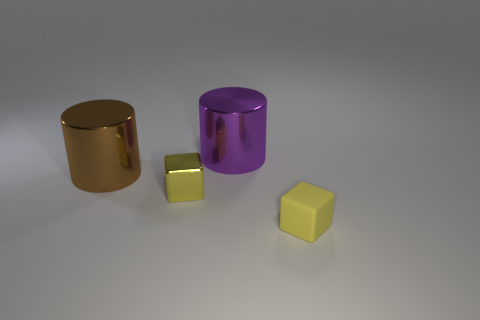What is the color of the metal object that is both on the left side of the purple cylinder and on the right side of the large brown shiny thing? yellow 